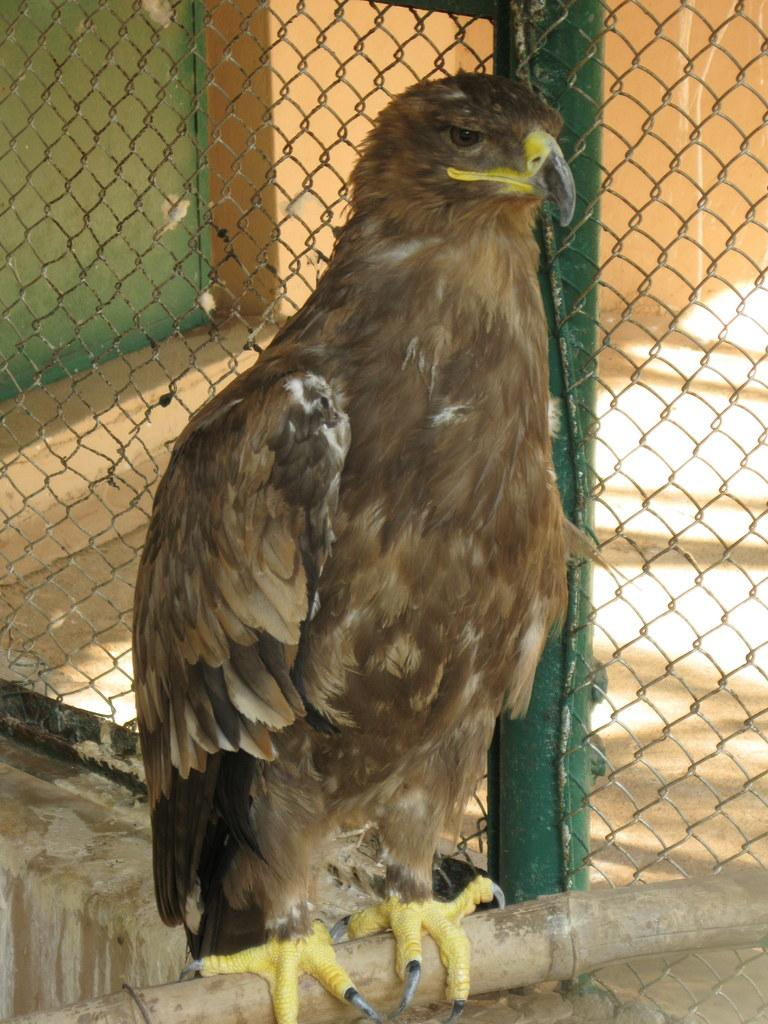What type of bird is in the image? There is a golden eagle in the image. What is the golden eagle perched on? The golden eagle is on a bamboo. What can be seen in the background of the image? There is a net and a window in the background of the image. What type of food is being cooked in the oven in the image? There is no oven or cooking activity present in the image. 